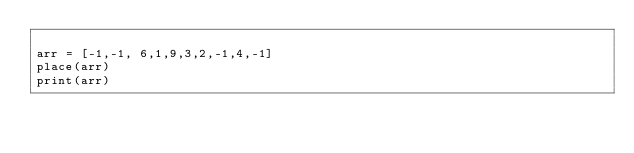Convert code to text. <code><loc_0><loc_0><loc_500><loc_500><_Python_>
arr = [-1,-1, 6,1,9,3,2,-1,4,-1]
place(arr)
print(arr)
</code> 